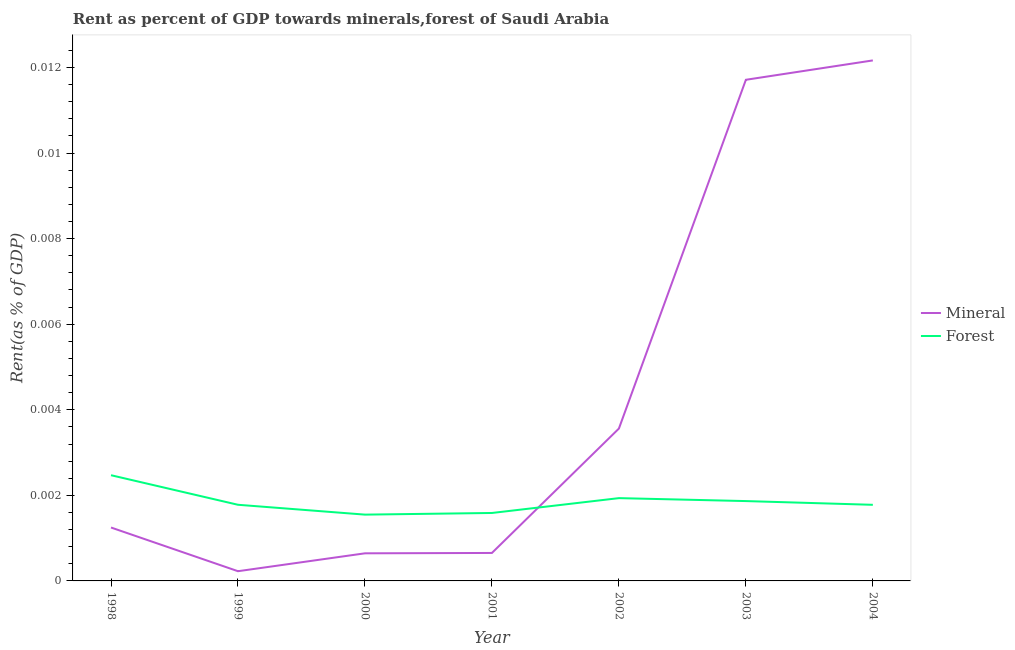How many different coloured lines are there?
Give a very brief answer. 2. Is the number of lines equal to the number of legend labels?
Make the answer very short. Yes. What is the forest rent in 1999?
Your answer should be compact. 0. Across all years, what is the maximum mineral rent?
Offer a very short reply. 0.01. Across all years, what is the minimum forest rent?
Provide a short and direct response. 0. In which year was the mineral rent minimum?
Provide a succinct answer. 1999. What is the total forest rent in the graph?
Offer a very short reply. 0.01. What is the difference between the forest rent in 2001 and that in 2004?
Provide a short and direct response. -0. What is the difference between the mineral rent in 1999 and the forest rent in 2000?
Offer a terse response. -0. What is the average forest rent per year?
Ensure brevity in your answer.  0. In the year 2000, what is the difference between the mineral rent and forest rent?
Offer a terse response. -0. What is the ratio of the mineral rent in 2002 to that in 2003?
Your answer should be compact. 0.3. Is the mineral rent in 1998 less than that in 2002?
Make the answer very short. Yes. What is the difference between the highest and the second highest mineral rent?
Offer a very short reply. 0. What is the difference between the highest and the lowest forest rent?
Make the answer very short. 0. In how many years, is the mineral rent greater than the average mineral rent taken over all years?
Give a very brief answer. 2. Is the sum of the mineral rent in 1998 and 2000 greater than the maximum forest rent across all years?
Keep it short and to the point. No. Does the forest rent monotonically increase over the years?
Offer a terse response. No. How many lines are there?
Make the answer very short. 2. How many years are there in the graph?
Provide a short and direct response. 7. What is the difference between two consecutive major ticks on the Y-axis?
Your answer should be compact. 0. Are the values on the major ticks of Y-axis written in scientific E-notation?
Provide a short and direct response. No. Does the graph contain grids?
Offer a terse response. No. Where does the legend appear in the graph?
Your answer should be compact. Center right. How many legend labels are there?
Give a very brief answer. 2. How are the legend labels stacked?
Give a very brief answer. Vertical. What is the title of the graph?
Your response must be concise. Rent as percent of GDP towards minerals,forest of Saudi Arabia. What is the label or title of the X-axis?
Your answer should be very brief. Year. What is the label or title of the Y-axis?
Your answer should be very brief. Rent(as % of GDP). What is the Rent(as % of GDP) of Mineral in 1998?
Your answer should be compact. 0. What is the Rent(as % of GDP) of Forest in 1998?
Ensure brevity in your answer.  0. What is the Rent(as % of GDP) of Mineral in 1999?
Your response must be concise. 0. What is the Rent(as % of GDP) of Forest in 1999?
Provide a short and direct response. 0. What is the Rent(as % of GDP) in Mineral in 2000?
Offer a terse response. 0. What is the Rent(as % of GDP) in Forest in 2000?
Give a very brief answer. 0. What is the Rent(as % of GDP) of Mineral in 2001?
Your response must be concise. 0. What is the Rent(as % of GDP) of Forest in 2001?
Provide a short and direct response. 0. What is the Rent(as % of GDP) in Mineral in 2002?
Your answer should be compact. 0. What is the Rent(as % of GDP) in Forest in 2002?
Give a very brief answer. 0. What is the Rent(as % of GDP) of Mineral in 2003?
Give a very brief answer. 0.01. What is the Rent(as % of GDP) in Forest in 2003?
Keep it short and to the point. 0. What is the Rent(as % of GDP) of Mineral in 2004?
Provide a short and direct response. 0.01. What is the Rent(as % of GDP) of Forest in 2004?
Provide a succinct answer. 0. Across all years, what is the maximum Rent(as % of GDP) of Mineral?
Offer a very short reply. 0.01. Across all years, what is the maximum Rent(as % of GDP) in Forest?
Your answer should be very brief. 0. Across all years, what is the minimum Rent(as % of GDP) in Mineral?
Offer a very short reply. 0. Across all years, what is the minimum Rent(as % of GDP) of Forest?
Your answer should be very brief. 0. What is the total Rent(as % of GDP) in Mineral in the graph?
Provide a short and direct response. 0.03. What is the total Rent(as % of GDP) of Forest in the graph?
Your answer should be very brief. 0.01. What is the difference between the Rent(as % of GDP) of Forest in 1998 and that in 1999?
Your answer should be compact. 0. What is the difference between the Rent(as % of GDP) of Mineral in 1998 and that in 2000?
Ensure brevity in your answer.  0. What is the difference between the Rent(as % of GDP) of Forest in 1998 and that in 2000?
Offer a terse response. 0. What is the difference between the Rent(as % of GDP) in Mineral in 1998 and that in 2001?
Make the answer very short. 0. What is the difference between the Rent(as % of GDP) in Forest in 1998 and that in 2001?
Make the answer very short. 0. What is the difference between the Rent(as % of GDP) in Mineral in 1998 and that in 2002?
Provide a succinct answer. -0. What is the difference between the Rent(as % of GDP) of Forest in 1998 and that in 2002?
Offer a very short reply. 0. What is the difference between the Rent(as % of GDP) of Mineral in 1998 and that in 2003?
Give a very brief answer. -0.01. What is the difference between the Rent(as % of GDP) in Forest in 1998 and that in 2003?
Provide a succinct answer. 0. What is the difference between the Rent(as % of GDP) in Mineral in 1998 and that in 2004?
Your response must be concise. -0.01. What is the difference between the Rent(as % of GDP) in Forest in 1998 and that in 2004?
Ensure brevity in your answer.  0. What is the difference between the Rent(as % of GDP) in Mineral in 1999 and that in 2000?
Give a very brief answer. -0. What is the difference between the Rent(as % of GDP) in Forest in 1999 and that in 2000?
Offer a terse response. 0. What is the difference between the Rent(as % of GDP) of Mineral in 1999 and that in 2001?
Give a very brief answer. -0. What is the difference between the Rent(as % of GDP) in Forest in 1999 and that in 2001?
Provide a succinct answer. 0. What is the difference between the Rent(as % of GDP) in Mineral in 1999 and that in 2002?
Provide a short and direct response. -0. What is the difference between the Rent(as % of GDP) of Forest in 1999 and that in 2002?
Keep it short and to the point. -0. What is the difference between the Rent(as % of GDP) in Mineral in 1999 and that in 2003?
Your response must be concise. -0.01. What is the difference between the Rent(as % of GDP) of Forest in 1999 and that in 2003?
Your answer should be compact. -0. What is the difference between the Rent(as % of GDP) of Mineral in 1999 and that in 2004?
Offer a terse response. -0.01. What is the difference between the Rent(as % of GDP) of Mineral in 2000 and that in 2001?
Your response must be concise. -0. What is the difference between the Rent(as % of GDP) of Forest in 2000 and that in 2001?
Ensure brevity in your answer.  -0. What is the difference between the Rent(as % of GDP) of Mineral in 2000 and that in 2002?
Make the answer very short. -0. What is the difference between the Rent(as % of GDP) of Forest in 2000 and that in 2002?
Offer a terse response. -0. What is the difference between the Rent(as % of GDP) of Mineral in 2000 and that in 2003?
Your response must be concise. -0.01. What is the difference between the Rent(as % of GDP) in Forest in 2000 and that in 2003?
Your response must be concise. -0. What is the difference between the Rent(as % of GDP) of Mineral in 2000 and that in 2004?
Your response must be concise. -0.01. What is the difference between the Rent(as % of GDP) in Forest in 2000 and that in 2004?
Keep it short and to the point. -0. What is the difference between the Rent(as % of GDP) in Mineral in 2001 and that in 2002?
Keep it short and to the point. -0. What is the difference between the Rent(as % of GDP) in Forest in 2001 and that in 2002?
Offer a terse response. -0. What is the difference between the Rent(as % of GDP) of Mineral in 2001 and that in 2003?
Make the answer very short. -0.01. What is the difference between the Rent(as % of GDP) of Forest in 2001 and that in 2003?
Your answer should be compact. -0. What is the difference between the Rent(as % of GDP) of Mineral in 2001 and that in 2004?
Make the answer very short. -0.01. What is the difference between the Rent(as % of GDP) in Forest in 2001 and that in 2004?
Your response must be concise. -0. What is the difference between the Rent(as % of GDP) in Mineral in 2002 and that in 2003?
Provide a succinct answer. -0.01. What is the difference between the Rent(as % of GDP) of Forest in 2002 and that in 2003?
Your answer should be compact. 0. What is the difference between the Rent(as % of GDP) of Mineral in 2002 and that in 2004?
Offer a very short reply. -0.01. What is the difference between the Rent(as % of GDP) in Forest in 2002 and that in 2004?
Keep it short and to the point. 0. What is the difference between the Rent(as % of GDP) of Mineral in 2003 and that in 2004?
Give a very brief answer. -0. What is the difference between the Rent(as % of GDP) of Mineral in 1998 and the Rent(as % of GDP) of Forest in 1999?
Give a very brief answer. -0. What is the difference between the Rent(as % of GDP) of Mineral in 1998 and the Rent(as % of GDP) of Forest in 2000?
Provide a succinct answer. -0. What is the difference between the Rent(as % of GDP) of Mineral in 1998 and the Rent(as % of GDP) of Forest in 2001?
Your answer should be very brief. -0. What is the difference between the Rent(as % of GDP) of Mineral in 1998 and the Rent(as % of GDP) of Forest in 2002?
Your response must be concise. -0. What is the difference between the Rent(as % of GDP) of Mineral in 1998 and the Rent(as % of GDP) of Forest in 2003?
Your answer should be compact. -0. What is the difference between the Rent(as % of GDP) in Mineral in 1998 and the Rent(as % of GDP) in Forest in 2004?
Keep it short and to the point. -0. What is the difference between the Rent(as % of GDP) in Mineral in 1999 and the Rent(as % of GDP) in Forest in 2000?
Offer a very short reply. -0. What is the difference between the Rent(as % of GDP) of Mineral in 1999 and the Rent(as % of GDP) of Forest in 2001?
Give a very brief answer. -0. What is the difference between the Rent(as % of GDP) of Mineral in 1999 and the Rent(as % of GDP) of Forest in 2002?
Your answer should be compact. -0. What is the difference between the Rent(as % of GDP) of Mineral in 1999 and the Rent(as % of GDP) of Forest in 2003?
Give a very brief answer. -0. What is the difference between the Rent(as % of GDP) of Mineral in 1999 and the Rent(as % of GDP) of Forest in 2004?
Your response must be concise. -0. What is the difference between the Rent(as % of GDP) in Mineral in 2000 and the Rent(as % of GDP) in Forest in 2001?
Make the answer very short. -0. What is the difference between the Rent(as % of GDP) of Mineral in 2000 and the Rent(as % of GDP) of Forest in 2002?
Keep it short and to the point. -0. What is the difference between the Rent(as % of GDP) in Mineral in 2000 and the Rent(as % of GDP) in Forest in 2003?
Offer a terse response. -0. What is the difference between the Rent(as % of GDP) in Mineral in 2000 and the Rent(as % of GDP) in Forest in 2004?
Offer a very short reply. -0. What is the difference between the Rent(as % of GDP) of Mineral in 2001 and the Rent(as % of GDP) of Forest in 2002?
Keep it short and to the point. -0. What is the difference between the Rent(as % of GDP) of Mineral in 2001 and the Rent(as % of GDP) of Forest in 2003?
Offer a very short reply. -0. What is the difference between the Rent(as % of GDP) in Mineral in 2001 and the Rent(as % of GDP) in Forest in 2004?
Keep it short and to the point. -0. What is the difference between the Rent(as % of GDP) in Mineral in 2002 and the Rent(as % of GDP) in Forest in 2003?
Offer a terse response. 0. What is the difference between the Rent(as % of GDP) in Mineral in 2002 and the Rent(as % of GDP) in Forest in 2004?
Provide a succinct answer. 0. What is the difference between the Rent(as % of GDP) in Mineral in 2003 and the Rent(as % of GDP) in Forest in 2004?
Provide a succinct answer. 0.01. What is the average Rent(as % of GDP) of Mineral per year?
Provide a succinct answer. 0. What is the average Rent(as % of GDP) in Forest per year?
Provide a succinct answer. 0. In the year 1998, what is the difference between the Rent(as % of GDP) in Mineral and Rent(as % of GDP) in Forest?
Ensure brevity in your answer.  -0. In the year 1999, what is the difference between the Rent(as % of GDP) of Mineral and Rent(as % of GDP) of Forest?
Your response must be concise. -0. In the year 2000, what is the difference between the Rent(as % of GDP) in Mineral and Rent(as % of GDP) in Forest?
Make the answer very short. -0. In the year 2001, what is the difference between the Rent(as % of GDP) of Mineral and Rent(as % of GDP) of Forest?
Make the answer very short. -0. In the year 2002, what is the difference between the Rent(as % of GDP) of Mineral and Rent(as % of GDP) of Forest?
Ensure brevity in your answer.  0. In the year 2003, what is the difference between the Rent(as % of GDP) of Mineral and Rent(as % of GDP) of Forest?
Your answer should be very brief. 0.01. In the year 2004, what is the difference between the Rent(as % of GDP) in Mineral and Rent(as % of GDP) in Forest?
Keep it short and to the point. 0.01. What is the ratio of the Rent(as % of GDP) of Mineral in 1998 to that in 1999?
Ensure brevity in your answer.  5.5. What is the ratio of the Rent(as % of GDP) of Forest in 1998 to that in 1999?
Your answer should be very brief. 1.39. What is the ratio of the Rent(as % of GDP) of Mineral in 1998 to that in 2000?
Offer a very short reply. 1.93. What is the ratio of the Rent(as % of GDP) of Forest in 1998 to that in 2000?
Offer a very short reply. 1.59. What is the ratio of the Rent(as % of GDP) in Mineral in 1998 to that in 2001?
Provide a short and direct response. 1.91. What is the ratio of the Rent(as % of GDP) in Forest in 1998 to that in 2001?
Your answer should be very brief. 1.56. What is the ratio of the Rent(as % of GDP) in Mineral in 1998 to that in 2002?
Offer a very short reply. 0.35. What is the ratio of the Rent(as % of GDP) of Forest in 1998 to that in 2002?
Offer a terse response. 1.28. What is the ratio of the Rent(as % of GDP) of Mineral in 1998 to that in 2003?
Offer a terse response. 0.11. What is the ratio of the Rent(as % of GDP) of Forest in 1998 to that in 2003?
Provide a succinct answer. 1.32. What is the ratio of the Rent(as % of GDP) of Mineral in 1998 to that in 2004?
Provide a short and direct response. 0.1. What is the ratio of the Rent(as % of GDP) of Forest in 1998 to that in 2004?
Provide a short and direct response. 1.39. What is the ratio of the Rent(as % of GDP) in Mineral in 1999 to that in 2000?
Make the answer very short. 0.35. What is the ratio of the Rent(as % of GDP) in Forest in 1999 to that in 2000?
Your response must be concise. 1.15. What is the ratio of the Rent(as % of GDP) of Mineral in 1999 to that in 2001?
Ensure brevity in your answer.  0.35. What is the ratio of the Rent(as % of GDP) of Forest in 1999 to that in 2001?
Ensure brevity in your answer.  1.12. What is the ratio of the Rent(as % of GDP) of Mineral in 1999 to that in 2002?
Make the answer very short. 0.06. What is the ratio of the Rent(as % of GDP) of Forest in 1999 to that in 2002?
Offer a terse response. 0.92. What is the ratio of the Rent(as % of GDP) in Mineral in 1999 to that in 2003?
Provide a short and direct response. 0.02. What is the ratio of the Rent(as % of GDP) in Forest in 1999 to that in 2003?
Your response must be concise. 0.95. What is the ratio of the Rent(as % of GDP) of Mineral in 1999 to that in 2004?
Your answer should be compact. 0.02. What is the ratio of the Rent(as % of GDP) of Forest in 1999 to that in 2004?
Make the answer very short. 1. What is the ratio of the Rent(as % of GDP) in Mineral in 2000 to that in 2001?
Your response must be concise. 0.99. What is the ratio of the Rent(as % of GDP) of Forest in 2000 to that in 2001?
Offer a terse response. 0.98. What is the ratio of the Rent(as % of GDP) of Mineral in 2000 to that in 2002?
Offer a terse response. 0.18. What is the ratio of the Rent(as % of GDP) of Forest in 2000 to that in 2002?
Your answer should be compact. 0.8. What is the ratio of the Rent(as % of GDP) of Mineral in 2000 to that in 2003?
Your answer should be very brief. 0.06. What is the ratio of the Rent(as % of GDP) in Forest in 2000 to that in 2003?
Provide a succinct answer. 0.83. What is the ratio of the Rent(as % of GDP) of Mineral in 2000 to that in 2004?
Ensure brevity in your answer.  0.05. What is the ratio of the Rent(as % of GDP) of Forest in 2000 to that in 2004?
Give a very brief answer. 0.87. What is the ratio of the Rent(as % of GDP) in Mineral in 2001 to that in 2002?
Keep it short and to the point. 0.18. What is the ratio of the Rent(as % of GDP) of Forest in 2001 to that in 2002?
Keep it short and to the point. 0.82. What is the ratio of the Rent(as % of GDP) of Mineral in 2001 to that in 2003?
Your answer should be compact. 0.06. What is the ratio of the Rent(as % of GDP) of Forest in 2001 to that in 2003?
Your response must be concise. 0.85. What is the ratio of the Rent(as % of GDP) of Mineral in 2001 to that in 2004?
Make the answer very short. 0.05. What is the ratio of the Rent(as % of GDP) in Forest in 2001 to that in 2004?
Provide a short and direct response. 0.89. What is the ratio of the Rent(as % of GDP) in Mineral in 2002 to that in 2003?
Ensure brevity in your answer.  0.3. What is the ratio of the Rent(as % of GDP) of Forest in 2002 to that in 2003?
Ensure brevity in your answer.  1.04. What is the ratio of the Rent(as % of GDP) in Mineral in 2002 to that in 2004?
Offer a very short reply. 0.29. What is the ratio of the Rent(as % of GDP) of Forest in 2002 to that in 2004?
Your answer should be very brief. 1.09. What is the ratio of the Rent(as % of GDP) in Mineral in 2003 to that in 2004?
Your response must be concise. 0.96. What is the ratio of the Rent(as % of GDP) in Forest in 2003 to that in 2004?
Ensure brevity in your answer.  1.05. What is the difference between the highest and the second highest Rent(as % of GDP) in Forest?
Your answer should be very brief. 0. What is the difference between the highest and the lowest Rent(as % of GDP) of Mineral?
Give a very brief answer. 0.01. What is the difference between the highest and the lowest Rent(as % of GDP) of Forest?
Make the answer very short. 0. 